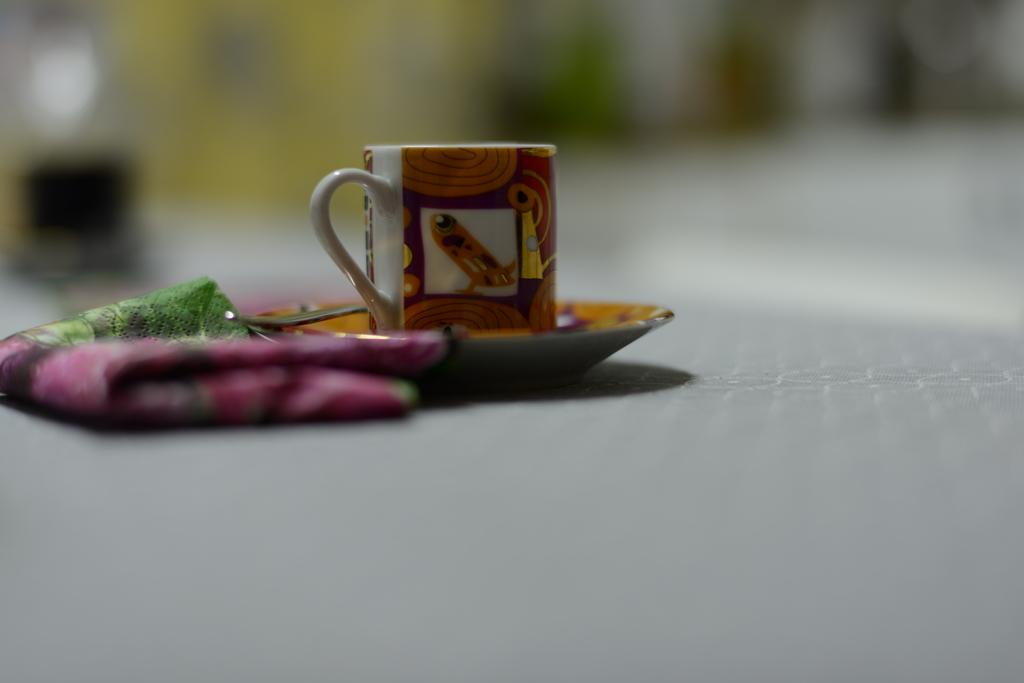What type of dishware is present in the image? There is a cup and a saucer in the image. What utensil is visible in the image? There is a spoon in the image. What item might be used for cleaning or wiping in the image? There is a napkin in the image. How many legs can be seen on the cup in the image? Cups do not have legs, so there are none visible in the image. 